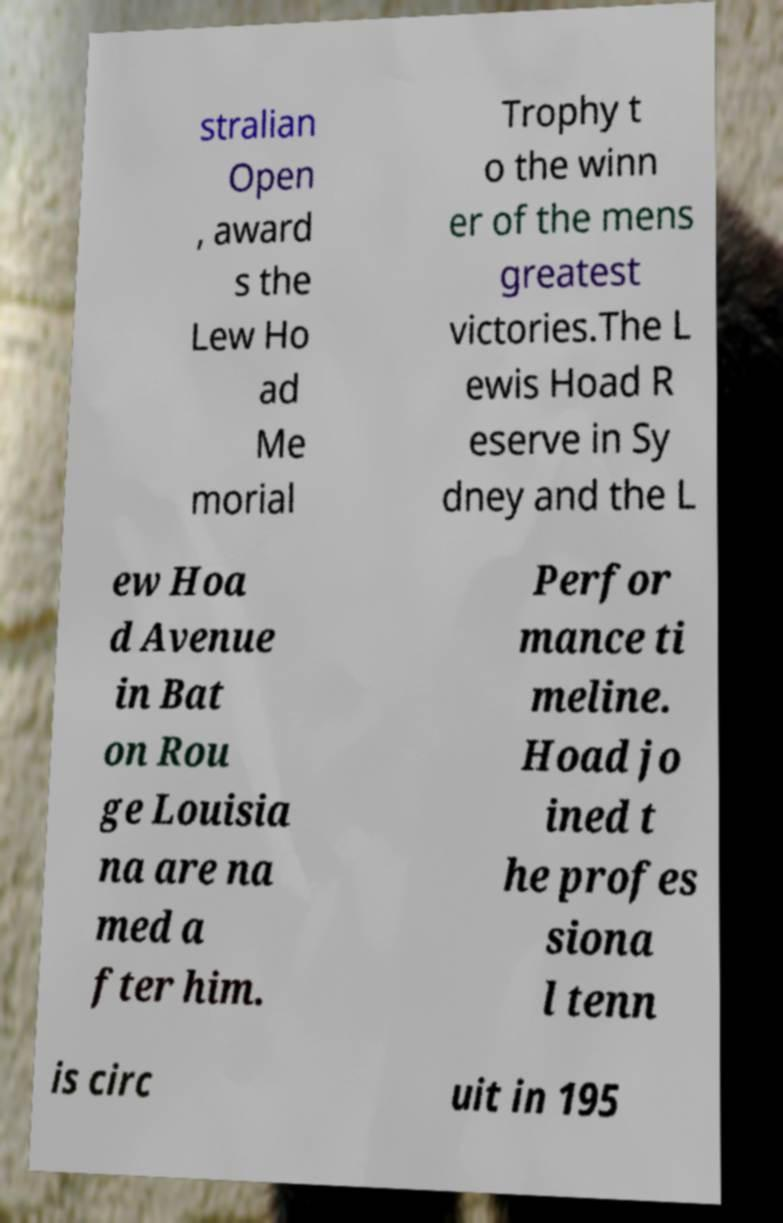What messages or text are displayed in this image? I need them in a readable, typed format. stralian Open , award s the Lew Ho ad Me morial Trophy t o the winn er of the mens greatest victories.The L ewis Hoad R eserve in Sy dney and the L ew Hoa d Avenue in Bat on Rou ge Louisia na are na med a fter him. Perfor mance ti meline. Hoad jo ined t he profes siona l tenn is circ uit in 195 